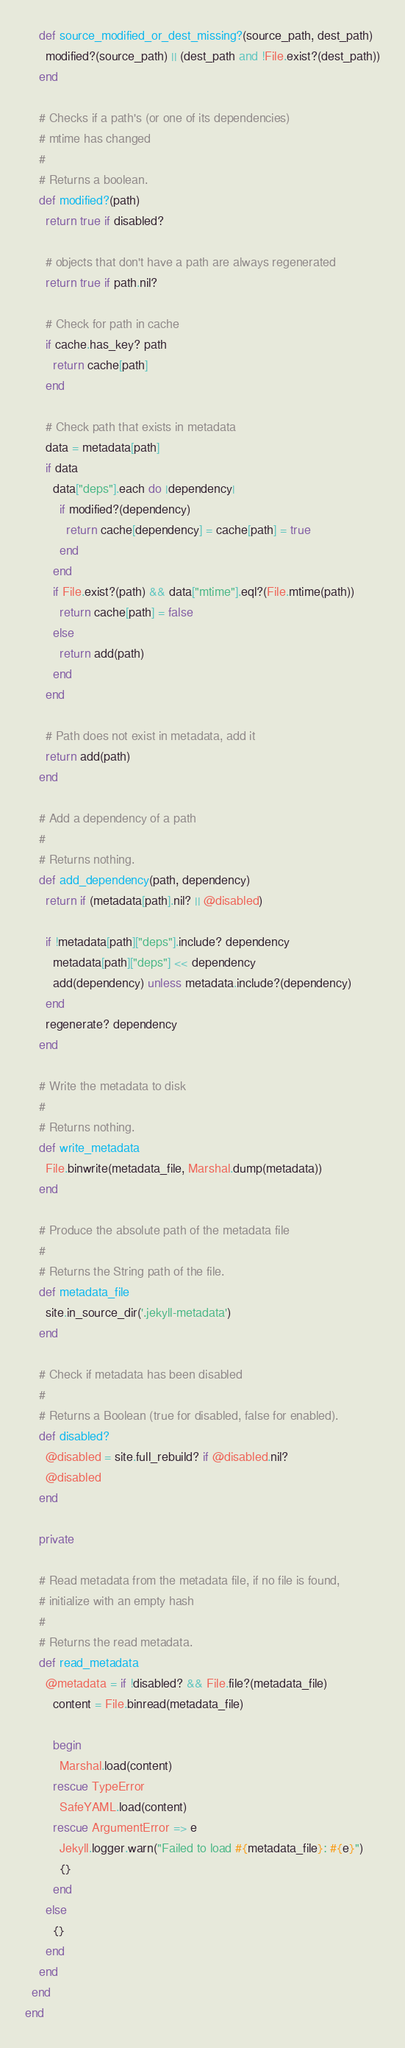<code> <loc_0><loc_0><loc_500><loc_500><_Ruby_>    def source_modified_or_dest_missing?(source_path, dest_path)
      modified?(source_path) || (dest_path and !File.exist?(dest_path))
    end

    # Checks if a path's (or one of its dependencies)
    # mtime has changed
    #
    # Returns a boolean.
    def modified?(path)
      return true if disabled?

      # objects that don't have a path are always regenerated
      return true if path.nil? 

      # Check for path in cache
      if cache.has_key? path
        return cache[path]
      end

      # Check path that exists in metadata
      data = metadata[path]
      if data
        data["deps"].each do |dependency|
          if modified?(dependency)
            return cache[dependency] = cache[path] = true
          end
        end
        if File.exist?(path) && data["mtime"].eql?(File.mtime(path))
          return cache[path] = false
        else
          return add(path)
        end
      end

      # Path does not exist in metadata, add it
      return add(path)
    end

    # Add a dependency of a path
    #
    # Returns nothing.
    def add_dependency(path, dependency)
      return if (metadata[path].nil? || @disabled)

      if !metadata[path]["deps"].include? dependency
        metadata[path]["deps"] << dependency
        add(dependency) unless metadata.include?(dependency)
      end
      regenerate? dependency
    end

    # Write the metadata to disk
    #
    # Returns nothing.
    def write_metadata
      File.binwrite(metadata_file, Marshal.dump(metadata))
    end

    # Produce the absolute path of the metadata file
    #
    # Returns the String path of the file.
    def metadata_file
      site.in_source_dir('.jekyll-metadata')
    end

    # Check if metadata has been disabled
    #
    # Returns a Boolean (true for disabled, false for enabled).
    def disabled?
      @disabled = site.full_rebuild? if @disabled.nil?
      @disabled
    end

    private

    # Read metadata from the metadata file, if no file is found,
    # initialize with an empty hash
    #
    # Returns the read metadata.
    def read_metadata
      @metadata = if !disabled? && File.file?(metadata_file)
        content = File.binread(metadata_file)

        begin
          Marshal.load(content)
        rescue TypeError
          SafeYAML.load(content)
        rescue ArgumentError => e
          Jekyll.logger.warn("Failed to load #{metadata_file}: #{e}")
          {}
        end
      else
        {}
      end
    end
  end
end
</code> 